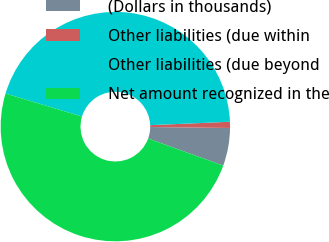Convert chart to OTSL. <chart><loc_0><loc_0><loc_500><loc_500><pie_chart><fcel>(Dollars in thousands)<fcel>Other liabilities (due within<fcel>Other liabilities (due beyond<fcel>Net amount recognized in the<nl><fcel>5.33%<fcel>0.86%<fcel>44.67%<fcel>49.14%<nl></chart> 